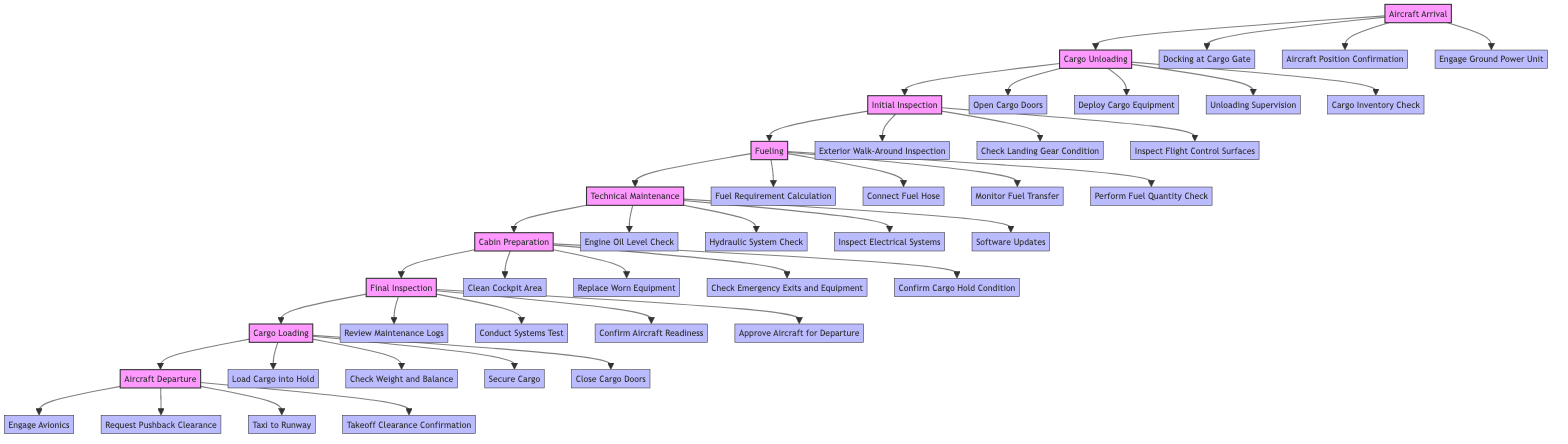What are the main nodes in the diagram? The main nodes represent significant stages in the Ground Handling and Maintenance Cycle, which are: Aircraft Arrival, Cargo Unloading, Initial Inspection, Fueling, Technical Maintenance, Cabin Preparation, Final Inspection, Cargo Loading, and Aircraft Departure.
Answer: Aircraft Arrival, Cargo Unloading, Initial Inspection, Fueling, Technical Maintenance, Cabin Preparation, Final Inspection, Cargo Loading, Aircraft Departure How many actions are listed under Fueling? The Fueling node has four actions connected to it: Fuel Requirement Calculation, Connect Fuel Hose, Monitor Fuel Transfer, and Perform Fuel Quantity Check, totaling four actions.
Answer: 4 Which action follows Cargo Unloading? After the Cargo Unloading node, the next process in the sequence is the Initial Inspection, indicating that the action sequence moves from unloading to inspecting.
Answer: Initial Inspection What do the actions in the Final Inspection node focus on? The actions in the Final Inspection node focus on a review of documentation and confirming aircraft readiness, specifically: Review Maintenance Logs, Conduct Systems Test, Confirm Aircraft Readiness, and Approve Aircraft for Departure.
Answer: Review Maintenance Logs, Conduct Systems Test, Confirm Aircraft Readiness, Approve Aircraft for Departure What is the first action listed under Aircraft Departure? The first action listed under the Aircraft Departure node is Engage Avionics, indicating that this is the starting point for preparing the aircraft for departure.
Answer: Engage Avionics How many nodes are there in total within the diagram? The diagram comprises a total of nine main process nodes that guide the Ground Handling and Maintenance Cycle from arrival to departure.
Answer: 9 What is the action that precedes Cargo Loading? The node that directly precedes Cargo Loading is Final Inspection, signifying that the final checks must occur before cargo loading can commence.
Answer: Final Inspection Which actions are involved in Technical Maintenance? The Technical Maintenance node includes four actions: Engine Oil Level Check, Hydraulic System Check, Inspect Electrical Systems, and Software Updates, all essential for aircraft functionality.
Answer: Engine Oil Level Check, Hydraulic System Check, Inspect Electrical Systems, Software Updates Which two processing nodes are linked without any actions in between? The two nodes that connect without any intervening actions are Final Inspection and Cargo Loading, indicating a direct transition between these two critical phases.
Answer: Final Inspection, Cargo Loading 